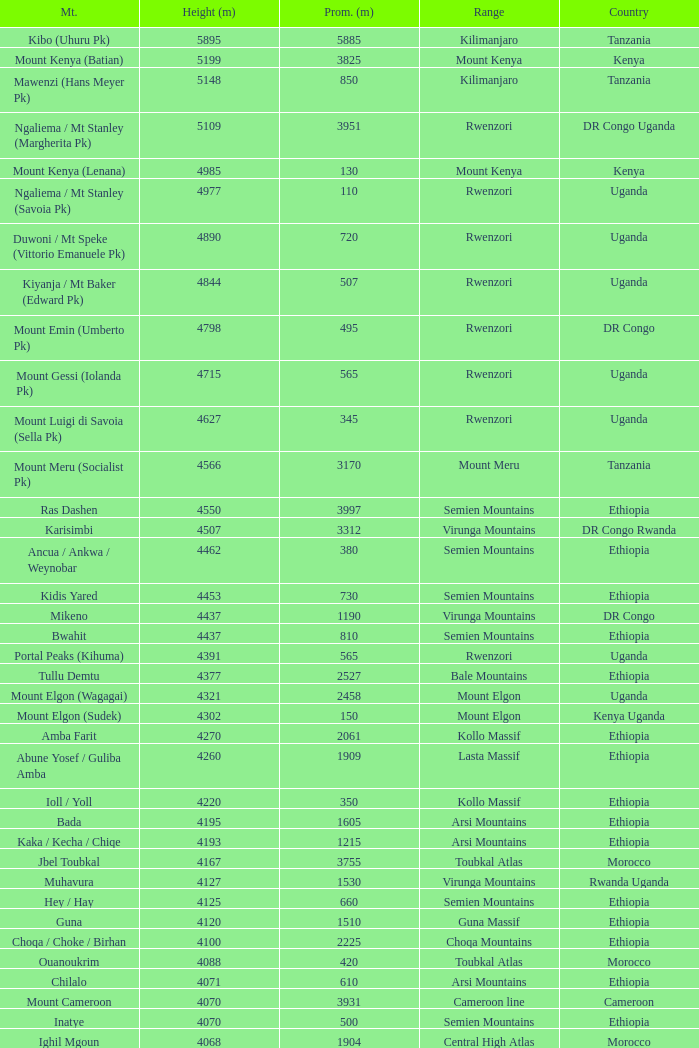Which Country has a Height (m) larger than 4100, and a Range of arsi mountains, and a Mountain of bada? Ethiopia. Could you parse the entire table as a dict? {'header': ['Mt.', 'Height (m)', 'Prom. (m)', 'Range', 'Country'], 'rows': [['Kibo (Uhuru Pk)', '5895', '5885', 'Kilimanjaro', 'Tanzania'], ['Mount Kenya (Batian)', '5199', '3825', 'Mount Kenya', 'Kenya'], ['Mawenzi (Hans Meyer Pk)', '5148', '850', 'Kilimanjaro', 'Tanzania'], ['Ngaliema / Mt Stanley (Margherita Pk)', '5109', '3951', 'Rwenzori', 'DR Congo Uganda'], ['Mount Kenya (Lenana)', '4985', '130', 'Mount Kenya', 'Kenya'], ['Ngaliema / Mt Stanley (Savoia Pk)', '4977', '110', 'Rwenzori', 'Uganda'], ['Duwoni / Mt Speke (Vittorio Emanuele Pk)', '4890', '720', 'Rwenzori', 'Uganda'], ['Kiyanja / Mt Baker (Edward Pk)', '4844', '507', 'Rwenzori', 'Uganda'], ['Mount Emin (Umberto Pk)', '4798', '495', 'Rwenzori', 'DR Congo'], ['Mount Gessi (Iolanda Pk)', '4715', '565', 'Rwenzori', 'Uganda'], ['Mount Luigi di Savoia (Sella Pk)', '4627', '345', 'Rwenzori', 'Uganda'], ['Mount Meru (Socialist Pk)', '4566', '3170', 'Mount Meru', 'Tanzania'], ['Ras Dashen', '4550', '3997', 'Semien Mountains', 'Ethiopia'], ['Karisimbi', '4507', '3312', 'Virunga Mountains', 'DR Congo Rwanda'], ['Ancua / Ankwa / Weynobar', '4462', '380', 'Semien Mountains', 'Ethiopia'], ['Kidis Yared', '4453', '730', 'Semien Mountains', 'Ethiopia'], ['Mikeno', '4437', '1190', 'Virunga Mountains', 'DR Congo'], ['Bwahit', '4437', '810', 'Semien Mountains', 'Ethiopia'], ['Portal Peaks (Kihuma)', '4391', '565', 'Rwenzori', 'Uganda'], ['Tullu Demtu', '4377', '2527', 'Bale Mountains', 'Ethiopia'], ['Mount Elgon (Wagagai)', '4321', '2458', 'Mount Elgon', 'Uganda'], ['Mount Elgon (Sudek)', '4302', '150', 'Mount Elgon', 'Kenya Uganda'], ['Amba Farit', '4270', '2061', 'Kollo Massif', 'Ethiopia'], ['Abune Yosef / Guliba Amba', '4260', '1909', 'Lasta Massif', 'Ethiopia'], ['Ioll / Yoll', '4220', '350', 'Kollo Massif', 'Ethiopia'], ['Bada', '4195', '1605', 'Arsi Mountains', 'Ethiopia'], ['Kaka / Kecha / Chiqe', '4193', '1215', 'Arsi Mountains', 'Ethiopia'], ['Jbel Toubkal', '4167', '3755', 'Toubkal Atlas', 'Morocco'], ['Muhavura', '4127', '1530', 'Virunga Mountains', 'Rwanda Uganda'], ['Hey / Hay', '4125', '660', 'Semien Mountains', 'Ethiopia'], ['Guna', '4120', '1510', 'Guna Massif', 'Ethiopia'], ['Choqa / Choke / Birhan', '4100', '2225', 'Choqa Mountains', 'Ethiopia'], ['Ouanoukrim', '4088', '420', 'Toubkal Atlas', 'Morocco'], ['Chilalo', '4071', '610', 'Arsi Mountains', 'Ethiopia'], ['Mount Cameroon', '4070', '3931', 'Cameroon line', 'Cameroon'], ['Inatye', '4070', '500', 'Semien Mountains', 'Ethiopia'], ['Ighil Mgoun', '4068', '1904', 'Central High Atlas', 'Morocco'], ['Weshema / Wasema?', '4030', '420', 'Bale Mountains', 'Ethiopia'], ['Oldoinyo Lesatima', '4001', '2081', 'Aberdare Range', 'Kenya'], ["Jebel n'Tarourt / Tifnout / Iferouane", '3996', '910', 'Toubkal Atlas', 'Morocco'], ['Muggia', '3950', '500', 'Lasta Massif', 'Ethiopia'], ['Dubbai', '3941', '1540', 'Tigray Mountains', 'Ethiopia'], ['Taska n’Zat', '3912', '460', 'Toubkal Atlas', 'Morocco'], ['Aksouâl', '3903', '450', 'Toubkal Atlas', 'Morocco'], ['Mount Kinangop', '3902', '530', 'Aberdare Range', 'Kenya'], ['Cimbia', '3900', '590', 'Kollo Massif', 'Ethiopia'], ['Anrhemer / Ingehmar', '3892', '380', 'Toubkal Atlas', 'Morocco'], ['Ieciuol ?', '3840', '560', 'Kollo Massif', 'Ethiopia'], ['Kawa / Caua / Lajo', '3830', '475', 'Bale Mountains', 'Ethiopia'], ['Pt 3820', '3820', '450', 'Kollo Massif', 'Ethiopia'], ['Jbel Tignousti', '3819', '930', 'Central High Atlas', 'Morocco'], ['Filfo / Encuolo', '3805', '770', 'Arsi Mountains', 'Ethiopia'], ['Kosso Amba', '3805', '530', 'Lasta Massif', 'Ethiopia'], ['Jbel Ghat', '3781', '470', 'Central High Atlas', 'Morocco'], ['Baylamtu / Gavsigivla', '3777', '1120', 'Lasta Massif', 'Ethiopia'], ['Ouaougoulzat', '3763', '860', 'Central High Atlas', 'Morocco'], ['Somkaru', '3760', '530', 'Bale Mountains', 'Ethiopia'], ['Abieri', '3750', '780', 'Semien Mountains', 'Ethiopia'], ['Arin Ayachi', '3747', '1400', 'East High Atlas', 'Morocco'], ['Teide', '3718', '3718', 'Tenerife', 'Canary Islands'], ['Visoke / Bisoke', '3711', '585', 'Virunga Mountains', 'DR Congo Rwanda'], ['Sarenga', '3700', '1160', 'Tigray Mountains', 'Ethiopia'], ['Woti / Uoti', '3700', '1050', 'Eastern Escarpment', 'Ethiopia'], ['Pt 3700 (Kulsa?)', '3700', '490', 'Arsi Mountains', 'Ethiopia'], ['Loolmalassin', '3682', '2040', 'Crater Highlands', 'Tanzania'], ['Biala ?', '3680', '870', 'Lasta Massif', 'Ethiopia'], ['Azurki / Azourki', '3677', '790', 'Central High Atlas', 'Morocco'], ['Pt 3645', '3645', '910', 'Lasta Massif', 'Ethiopia'], ['Sabyinyo', '3634', '1010', 'Virunga Mountains', 'Rwanda DR Congo Uganda'], ['Mount Gurage / Guraghe', '3620', '1400', 'Gurage Mountains', 'Ethiopia'], ['Angour', '3616', '444', 'Toubkal Atlas', 'Morocco'], ['Jbel Igdat', '3615', '1609', 'West High Atlas', 'Morocco'], ["Jbel n'Anghomar", '3609', '1420', 'Central High Atlas', 'Morocco'], ['Yegura / Amba Moka', '3605', '420', 'Lasta Massif', 'Ethiopia'], ['Pt 3600 (Kitir?)', '3600', '870', 'Eastern Escarpment', 'Ethiopia'], ['Pt 3600', '3600', '610', 'Lasta Massif', 'Ethiopia'], ['Bar Meda high point', '3580', '520', 'Eastern Escarpment', 'Ethiopia'], ['Jbel Erdouz', '3579', '690', 'West High Atlas', 'Morocco'], ['Mount Gugu', '3570', '940', 'Mount Gugu', 'Ethiopia'], ['Gesh Megal (?)', '3570', '520', 'Gurage Mountains', 'Ethiopia'], ['Gughe', '3568', '2013', 'Balta Mountains', 'Ethiopia'], ['Megezez', '3565', '690', 'Eastern Escarpment', 'Ethiopia'], ['Pt 3555', '3555', '475', 'Lasta Massif', 'Ethiopia'], ['Jbel Tinergwet', '3551', '880', 'West High Atlas', 'Morocco'], ['Amba Alagi', '3550', '820', 'Tigray Mountains', 'Ethiopia'], ['Nakugen', '3530', '1510', 'Cherangany Hills', 'Kenya'], ['Gara Guda /Kara Gada', '3530', '900', 'Salale Mountains', 'Ethiopia'], ['Amonewas', '3530', '870', 'Choqa Mountains', 'Ethiopia'], ['Amedamit', '3530', '760', 'Choqa Mountains', 'Ethiopia'], ['Igoudamene', '3519', '550', 'Central High Atlas', 'Morocco'], ['Abuye Meda', '3505', '230', 'Eastern Escarpment', 'Ethiopia'], ['Thabana Ntlenyana', '3482', '2390', 'Drakensberg', 'Lesotho'], ['Mont Mohi', '3480', '1592', 'Mitumba Mountains', 'DR Congo'], ['Gahinga', '3474', '425', 'Virunga Mountains', 'Uganda Rwanda'], ['Nyiragongo', '3470', '1440', 'Virunga Mountains', 'DR Congo']]} 